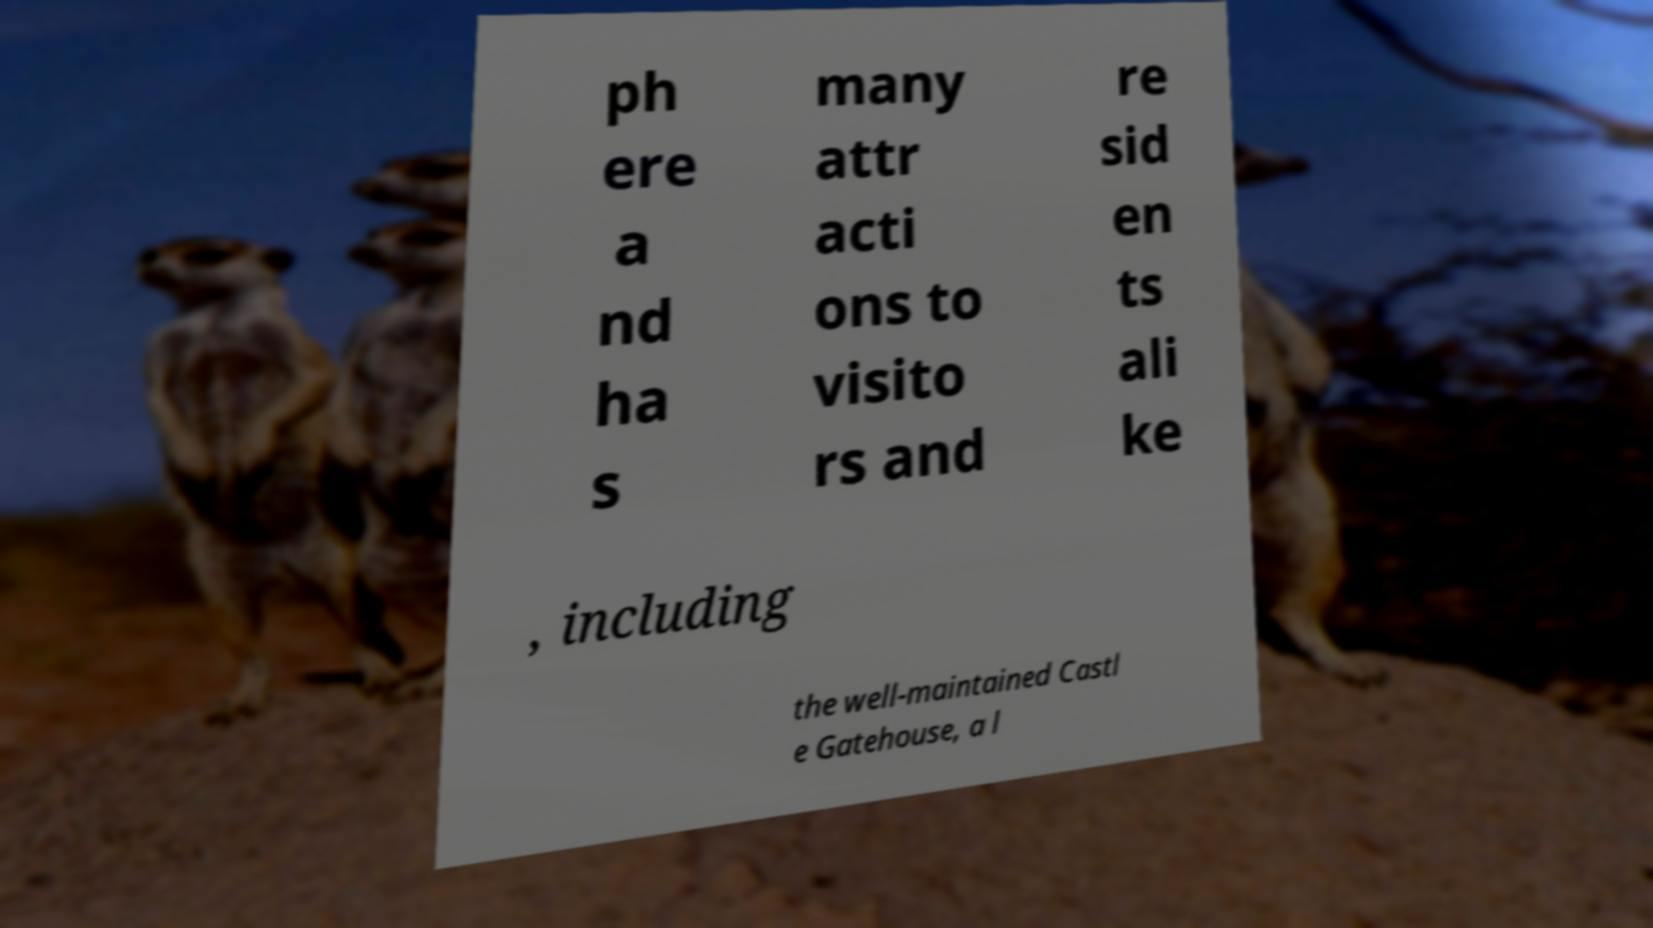Please identify and transcribe the text found in this image. ph ere a nd ha s many attr acti ons to visito rs and re sid en ts ali ke , including the well-maintained Castl e Gatehouse, a l 